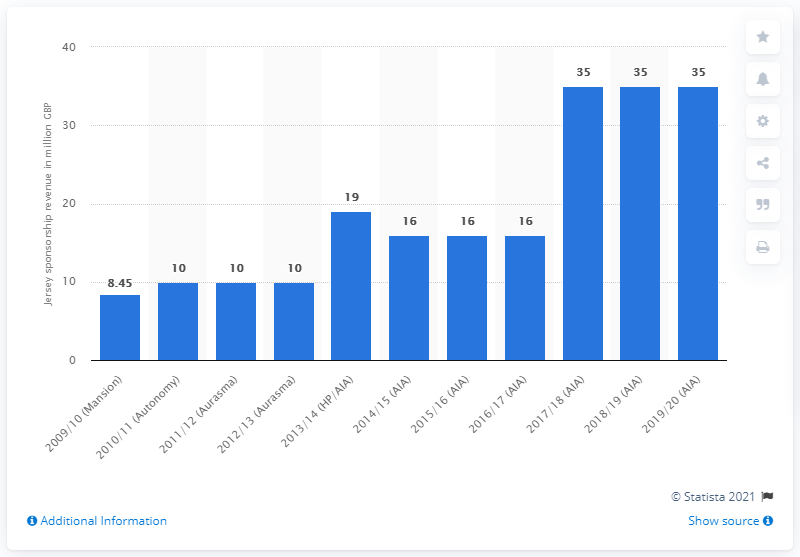Draw attention to some important aspects in this diagram. In the 2019/20 season, Tottenham Hotspur received 35 million US dollars from AIA, a significant amount of money. 